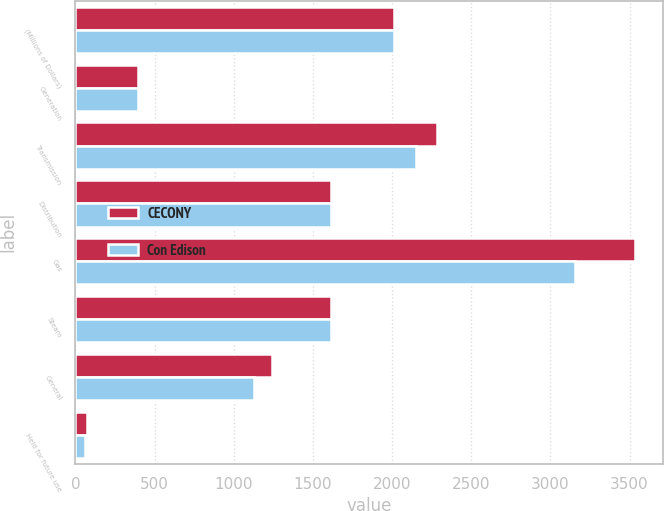Convert chart to OTSL. <chart><loc_0><loc_0><loc_500><loc_500><stacked_bar_chart><ecel><fcel>(Millions of Dollars)<fcel>Generation<fcel>Transmission<fcel>Distribution<fcel>Gas<fcel>Steam<fcel>General<fcel>Held for future use<nl><fcel>CECONY<fcel>2010<fcel>396<fcel>2284<fcel>1617<fcel>3535<fcel>1617<fcel>1241<fcel>72<nl><fcel>Con Edison<fcel>2010<fcel>396<fcel>2150<fcel>1617<fcel>3153<fcel>1617<fcel>1125<fcel>60<nl></chart> 